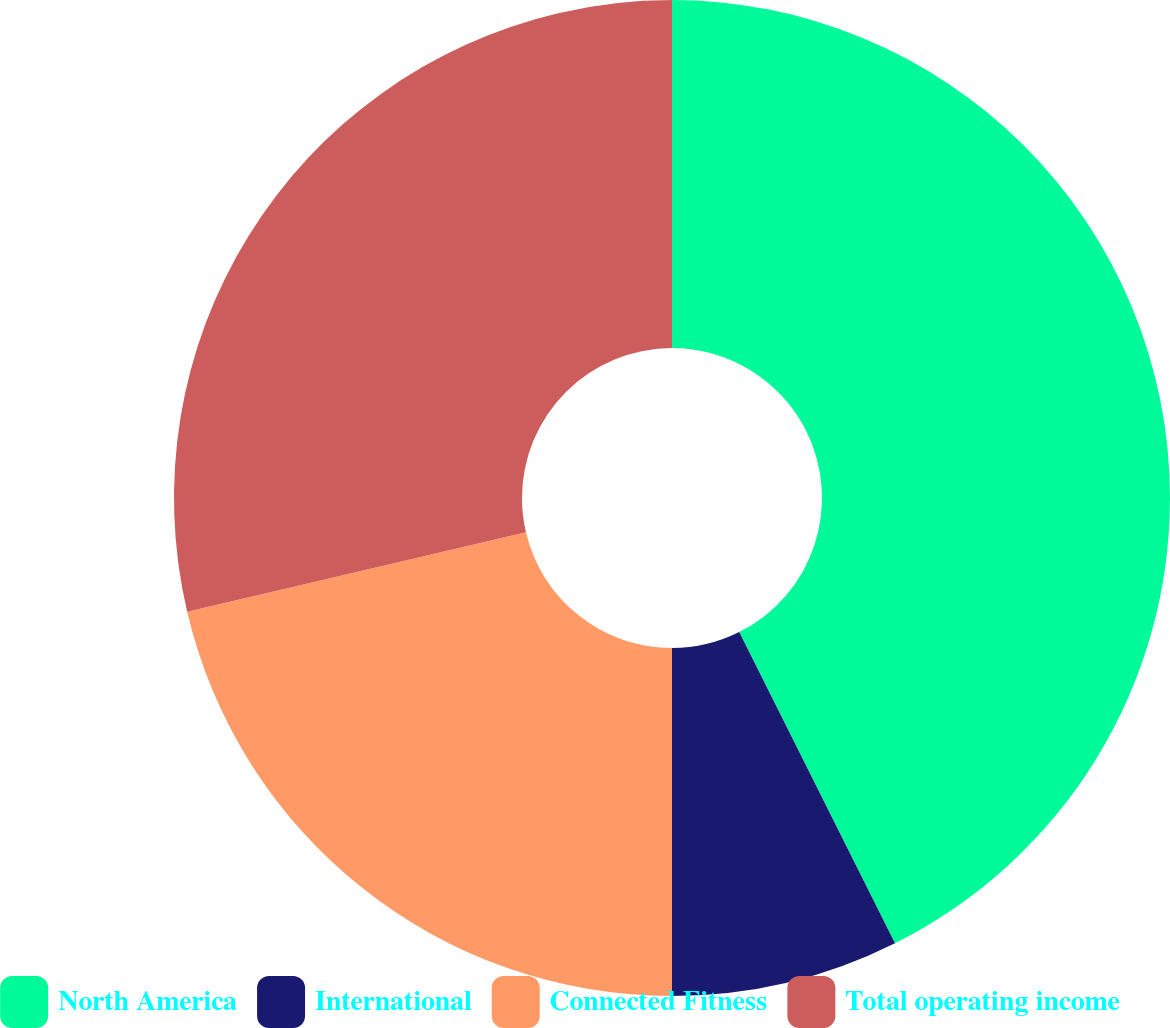Convert chart to OTSL. <chart><loc_0><loc_0><loc_500><loc_500><pie_chart><fcel>North America<fcel>International<fcel>Connected Fitness<fcel>Total operating income<nl><fcel>42.61%<fcel>7.39%<fcel>21.33%<fcel>28.67%<nl></chart> 